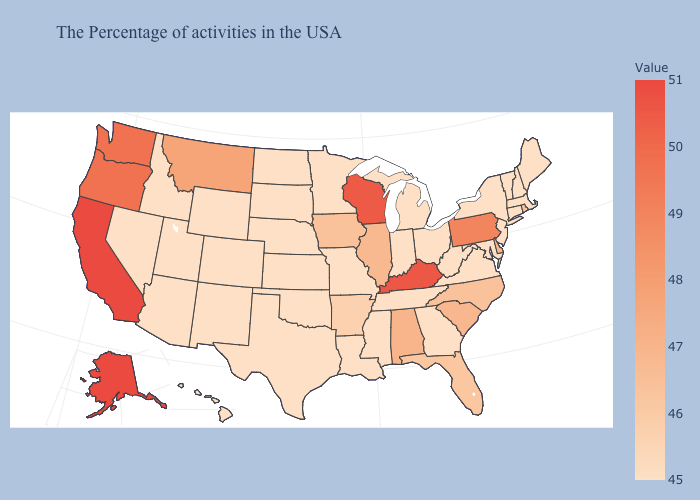Which states have the highest value in the USA?
Quick response, please. California, Alaska. Among the states that border Michigan , does Wisconsin have the highest value?
Give a very brief answer. Yes. Among the states that border Michigan , which have the lowest value?
Concise answer only. Ohio, Indiana. 